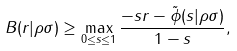Convert formula to latex. <formula><loc_0><loc_0><loc_500><loc_500>B ( r | \rho \| \sigma ) \geq \max _ { 0 \leq s \leq 1 } \frac { - s r - \tilde { \phi } ( s | \rho \| \sigma ) } { 1 - s } ,</formula> 